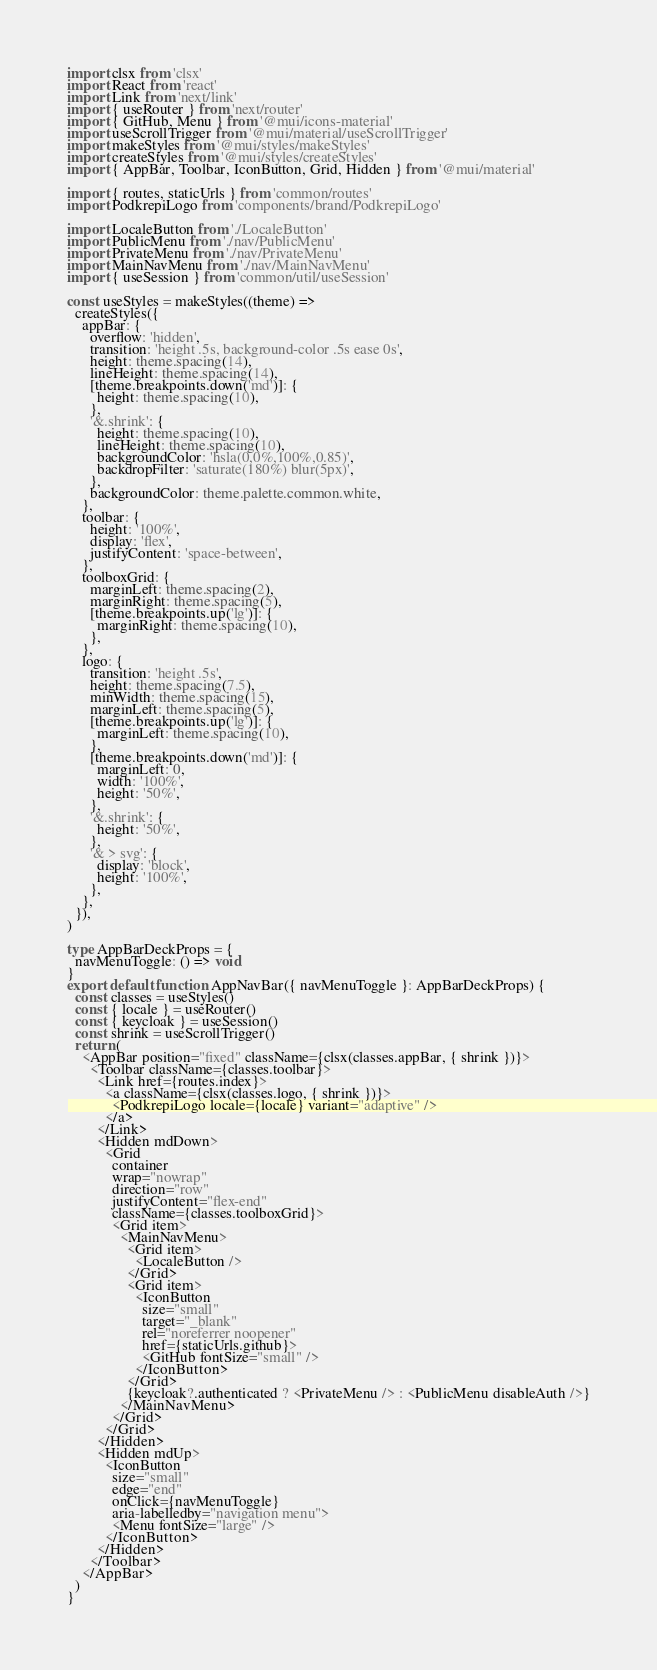<code> <loc_0><loc_0><loc_500><loc_500><_TypeScript_>import clsx from 'clsx'
import React from 'react'
import Link from 'next/link'
import { useRouter } from 'next/router'
import { GitHub, Menu } from '@mui/icons-material'
import useScrollTrigger from '@mui/material/useScrollTrigger'
import makeStyles from '@mui/styles/makeStyles'
import createStyles from '@mui/styles/createStyles'
import { AppBar, Toolbar, IconButton, Grid, Hidden } from '@mui/material'

import { routes, staticUrls } from 'common/routes'
import PodkrepiLogo from 'components/brand/PodkrepiLogo'

import LocaleButton from './LocaleButton'
import PublicMenu from './nav/PublicMenu'
import PrivateMenu from './nav/PrivateMenu'
import MainNavMenu from './nav/MainNavMenu'
import { useSession } from 'common/util/useSession'

const useStyles = makeStyles((theme) =>
  createStyles({
    appBar: {
      overflow: 'hidden',
      transition: 'height .5s, background-color .5s ease 0s',
      height: theme.spacing(14),
      lineHeight: theme.spacing(14),
      [theme.breakpoints.down('md')]: {
        height: theme.spacing(10),
      },
      '&.shrink': {
        height: theme.spacing(10),
        lineHeight: theme.spacing(10),
        backgroundColor: 'hsla(0,0%,100%,0.85)',
        backdropFilter: 'saturate(180%) blur(5px)',
      },
      backgroundColor: theme.palette.common.white,
    },
    toolbar: {
      height: '100%',
      display: 'flex',
      justifyContent: 'space-between',
    },
    toolboxGrid: {
      marginLeft: theme.spacing(2),
      marginRight: theme.spacing(5),
      [theme.breakpoints.up('lg')]: {
        marginRight: theme.spacing(10),
      },
    },
    logo: {
      transition: 'height .5s',
      height: theme.spacing(7.5),
      minWidth: theme.spacing(15),
      marginLeft: theme.spacing(5),
      [theme.breakpoints.up('lg')]: {
        marginLeft: theme.spacing(10),
      },
      [theme.breakpoints.down('md')]: {
        marginLeft: 0,
        width: '100%',
        height: '50%',
      },
      '&.shrink': {
        height: '50%',
      },
      '& > svg': {
        display: 'block',
        height: '100%',
      },
    },
  }),
)

type AppBarDeckProps = {
  navMenuToggle: () => void
}
export default function AppNavBar({ navMenuToggle }: AppBarDeckProps) {
  const classes = useStyles()
  const { locale } = useRouter()
  const { keycloak } = useSession()
  const shrink = useScrollTrigger()
  return (
    <AppBar position="fixed" className={clsx(classes.appBar, { shrink })}>
      <Toolbar className={classes.toolbar}>
        <Link href={routes.index}>
          <a className={clsx(classes.logo, { shrink })}>
            <PodkrepiLogo locale={locale} variant="adaptive" />
          </a>
        </Link>
        <Hidden mdDown>
          <Grid
            container
            wrap="nowrap"
            direction="row"
            justifyContent="flex-end"
            className={classes.toolboxGrid}>
            <Grid item>
              <MainNavMenu>
                <Grid item>
                  <LocaleButton />
                </Grid>
                <Grid item>
                  <IconButton
                    size="small"
                    target="_blank"
                    rel="noreferrer noopener"
                    href={staticUrls.github}>
                    <GitHub fontSize="small" />
                  </IconButton>
                </Grid>
                {keycloak?.authenticated ? <PrivateMenu /> : <PublicMenu disableAuth />}
              </MainNavMenu>
            </Grid>
          </Grid>
        </Hidden>
        <Hidden mdUp>
          <IconButton
            size="small"
            edge="end"
            onClick={navMenuToggle}
            aria-labelledby="navigation menu">
            <Menu fontSize="large" />
          </IconButton>
        </Hidden>
      </Toolbar>
    </AppBar>
  )
}
</code> 